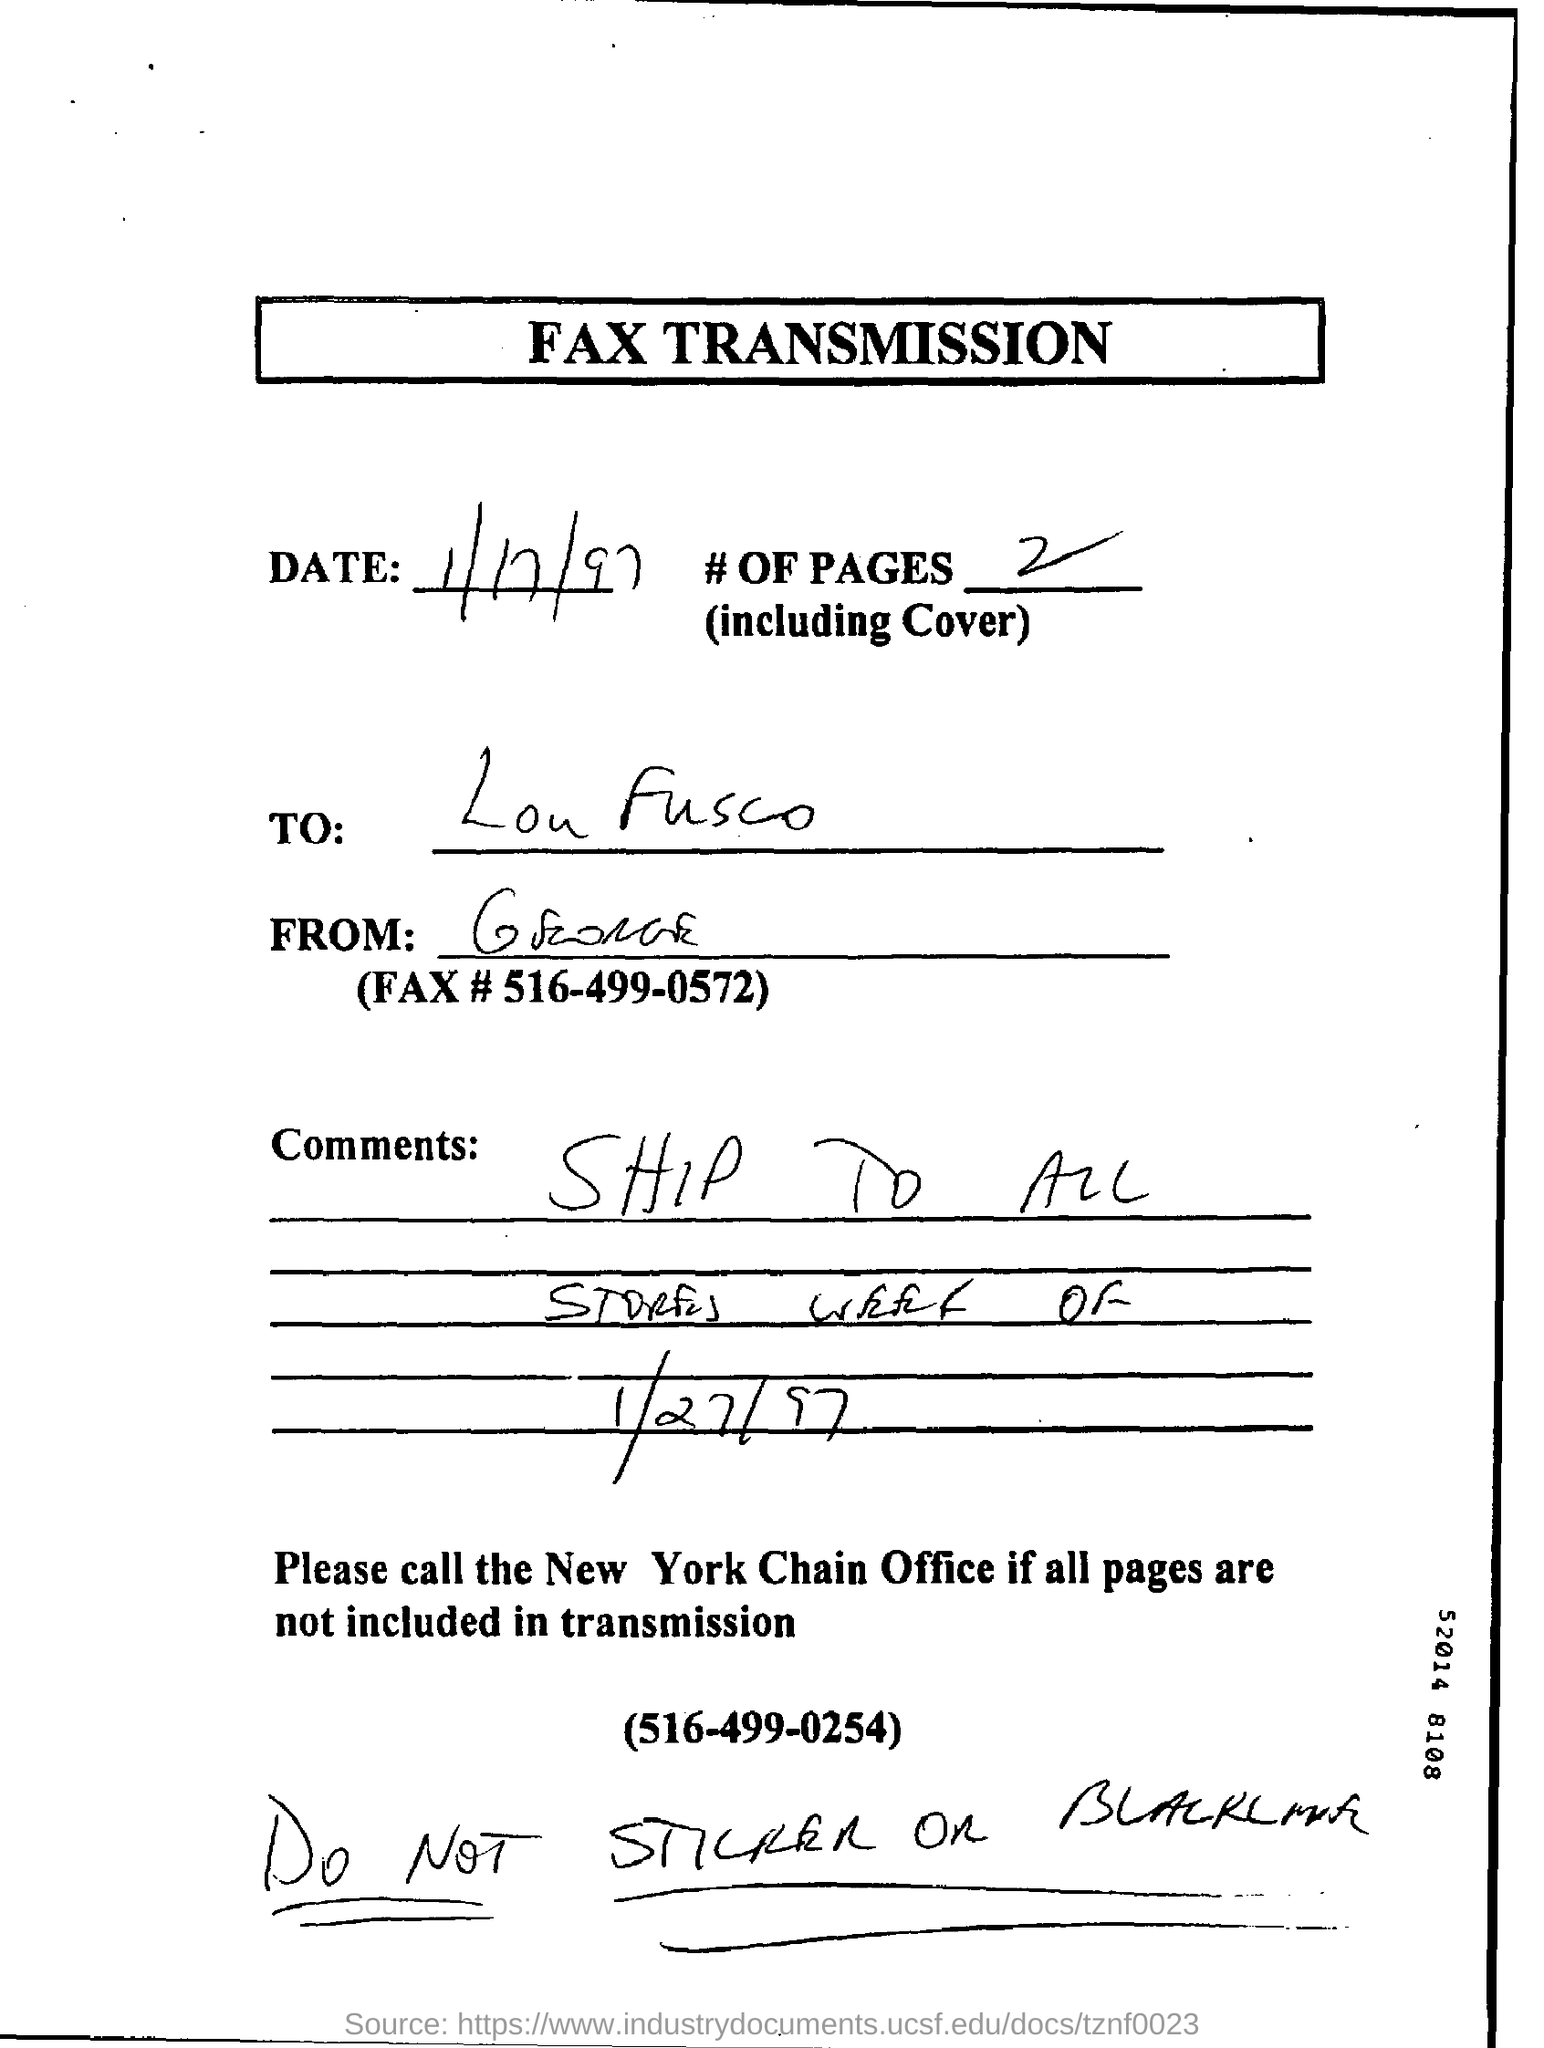Draw attention to some important aspects in this diagram. The date of fax transmission is January 17, 1997. The number of pages including the cover is two. 